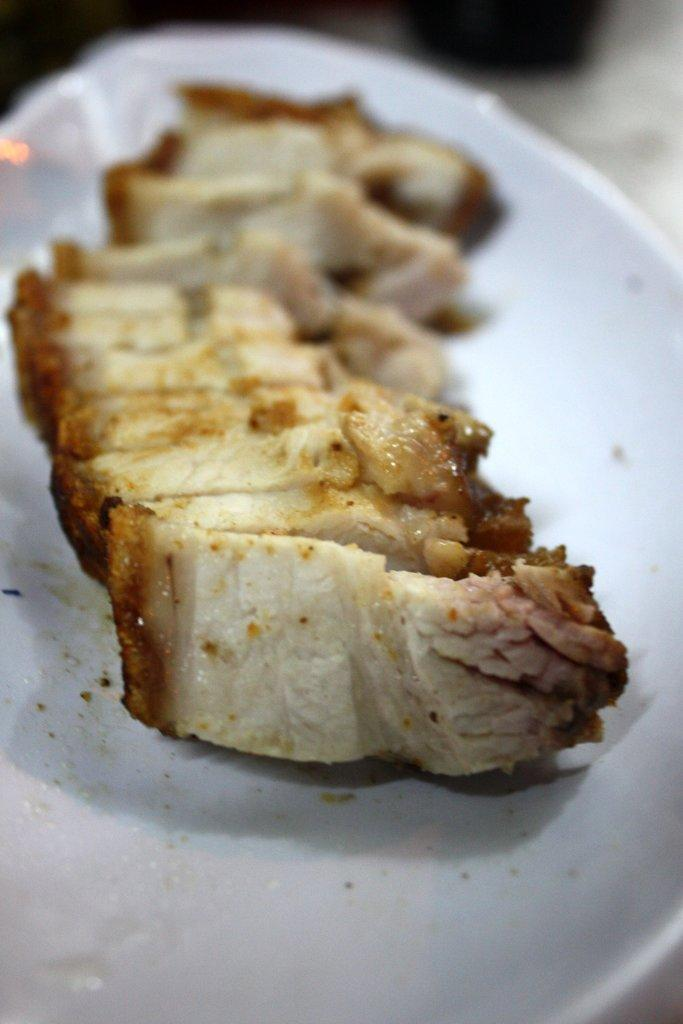What is on the plate that is visible in the image? There is a plate containing food in the image. How does the pot help the beginner kick the ball in the image? There is no pot or ball present in the image; it only features a plate containing food. 